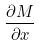<formula> <loc_0><loc_0><loc_500><loc_500>\frac { \partial M } { \partial x }</formula> 